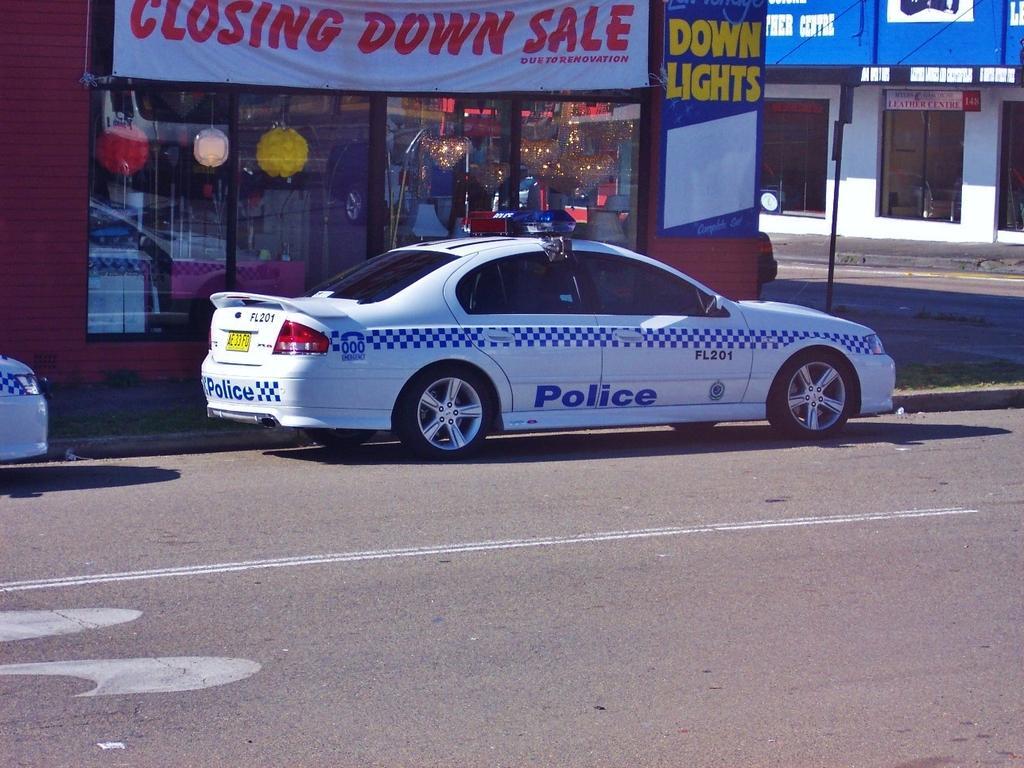Describe this image in one or two sentences. In this image I can see the vehicles on the road. To the side of the road I can see the buildings. I can see the banner and boards to the building. I can see the decorative objects inside building. 